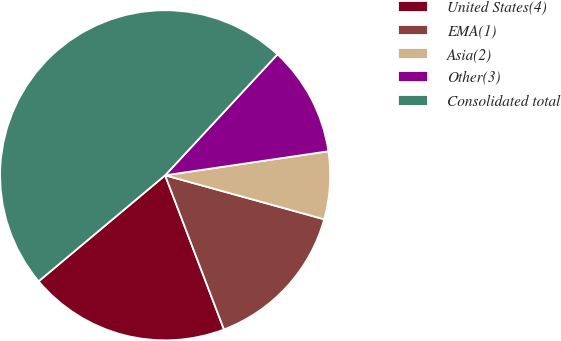Convert chart to OTSL. <chart><loc_0><loc_0><loc_500><loc_500><pie_chart><fcel>United States(4)<fcel>EMA(1)<fcel>Asia(2)<fcel>Other(3)<fcel>Consolidated total<nl><fcel>19.7%<fcel>14.9%<fcel>6.62%<fcel>10.76%<fcel>48.01%<nl></chart> 